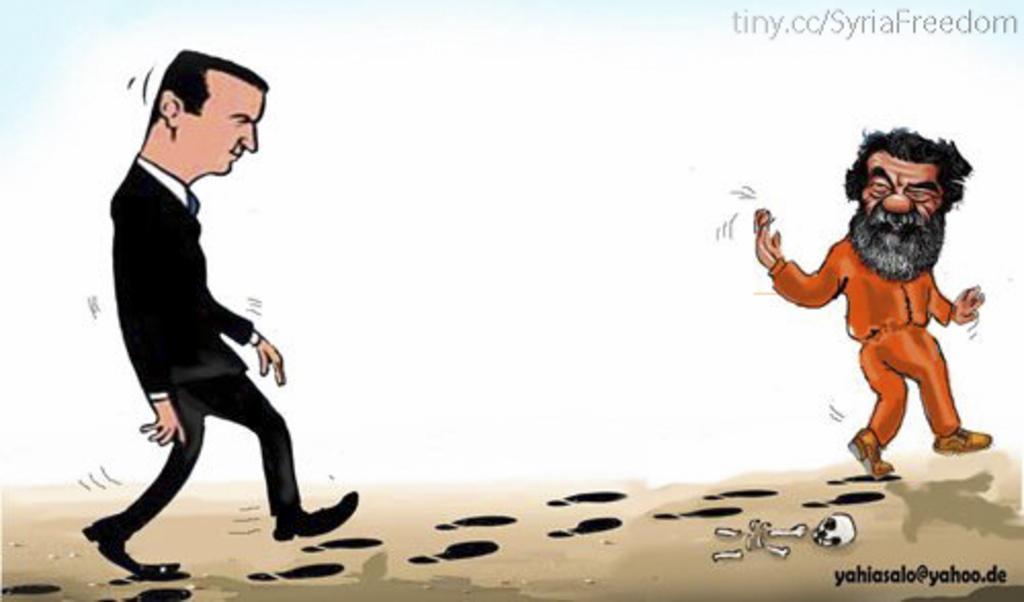Can you describe this image briefly? There is one cartoon picture of a person is on the left side of this image and on the right side of this image as well. We can see a watermark at the top of this image and at the bottom of this image. 